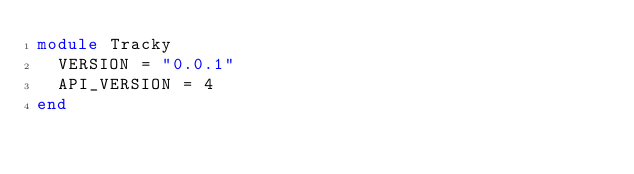<code> <loc_0><loc_0><loc_500><loc_500><_Ruby_>module Tracky
  VERSION = "0.0.1"
  API_VERSION = 4
end
</code> 